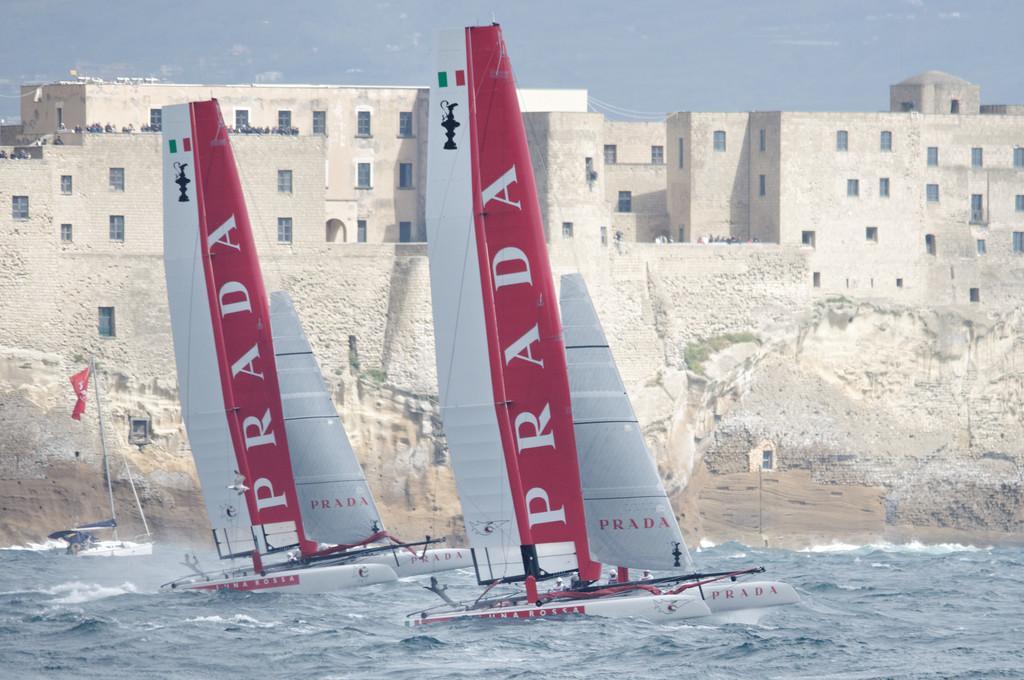How would you summarize this image in a sentence or two? In this picture I can see few boats in the water and few buildings and looks like few people standing on the buildings and a cloudy Sky. 